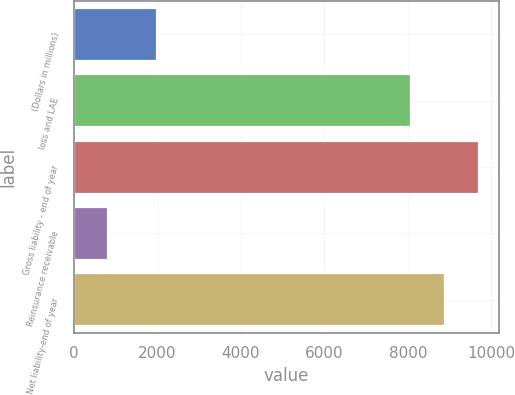<chart> <loc_0><loc_0><loc_500><loc_500><bar_chart><fcel>(Dollars in millions)<fcel>loss and LAE<fcel>Gross liability - end of year<fcel>Reinsurance receivable<fcel>Net liability-end of year<nl><fcel>2006<fcel>8078.9<fcel>9694.68<fcel>809.1<fcel>8886.79<nl></chart> 